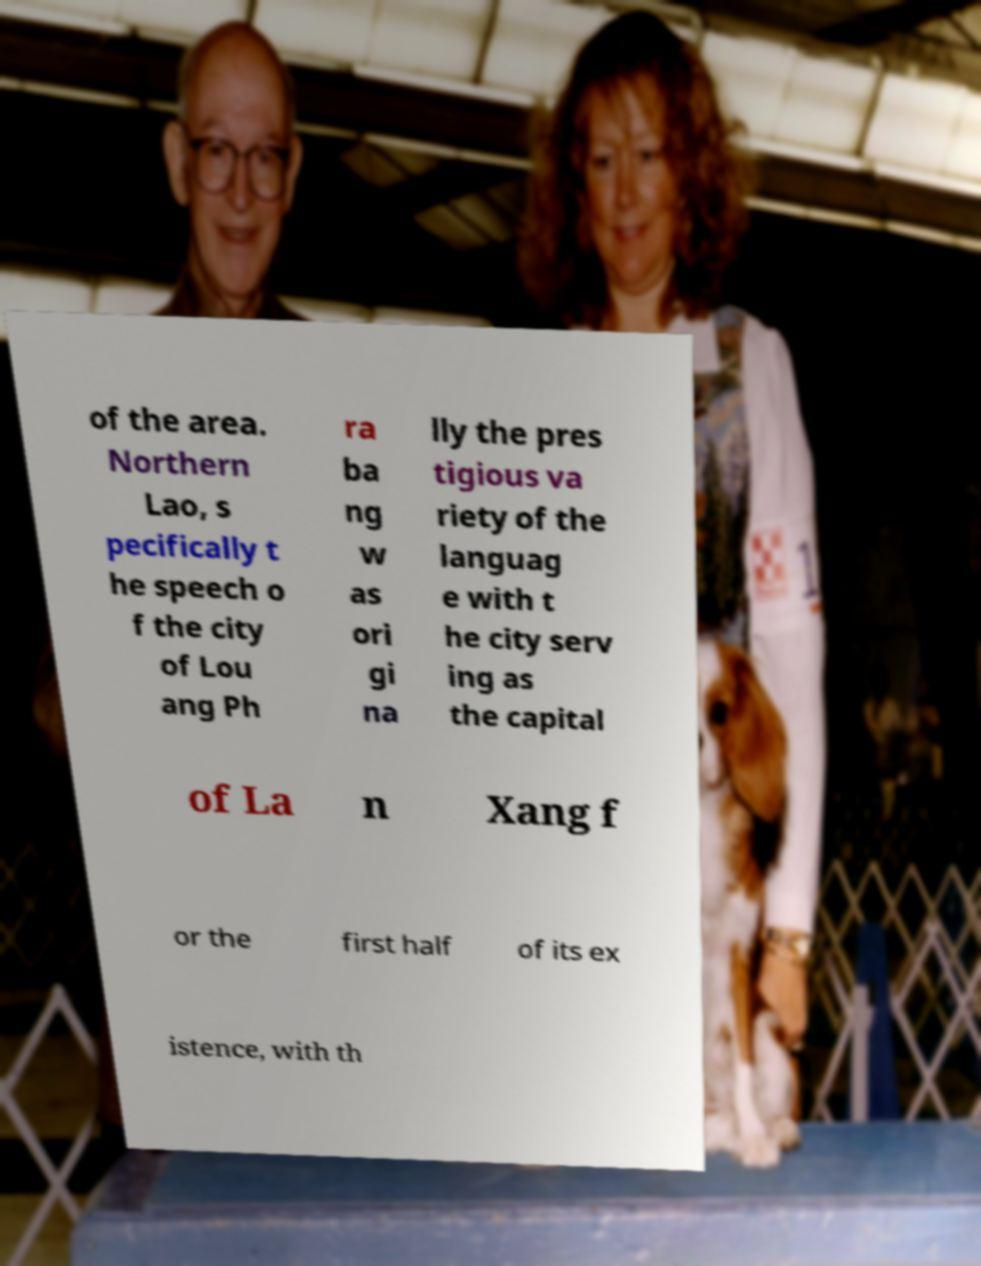Can you read and provide the text displayed in the image?This photo seems to have some interesting text. Can you extract and type it out for me? of the area. Northern Lao, s pecifically t he speech o f the city of Lou ang Ph ra ba ng w as ori gi na lly the pres tigious va riety of the languag e with t he city serv ing as the capital of La n Xang f or the first half of its ex istence, with th 